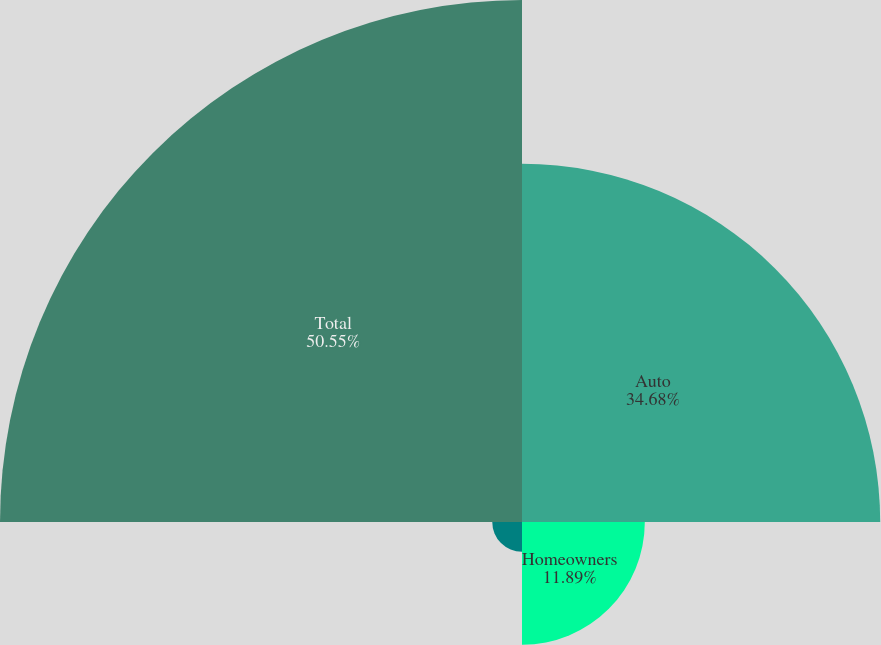<chart> <loc_0><loc_0><loc_500><loc_500><pie_chart><fcel>Auto<fcel>Homeowners<fcel>Other personal lines<fcel>Total<nl><fcel>34.68%<fcel>11.89%<fcel>2.88%<fcel>50.54%<nl></chart> 